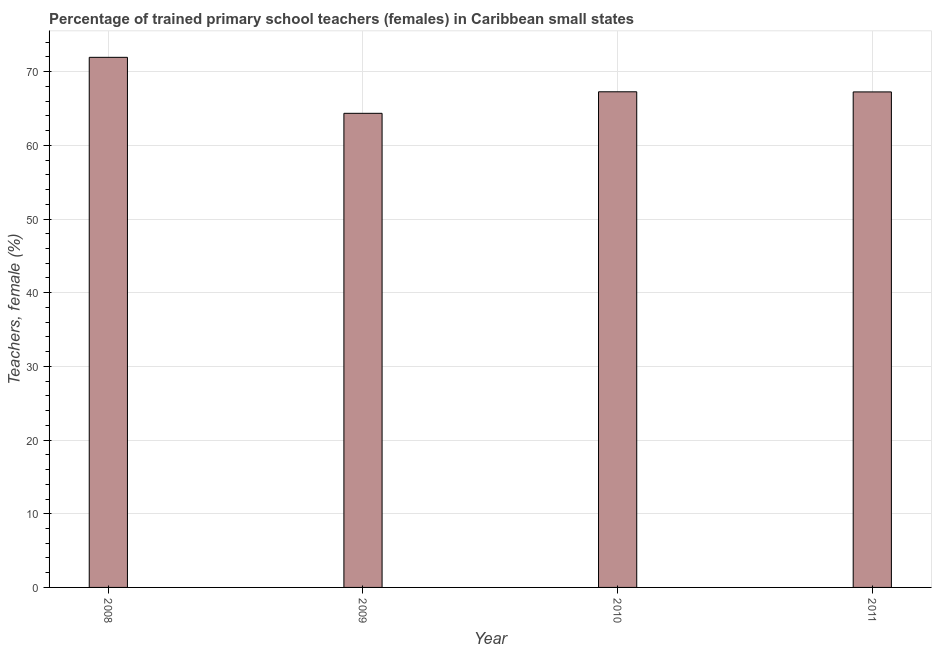Does the graph contain grids?
Your answer should be very brief. Yes. What is the title of the graph?
Your answer should be compact. Percentage of trained primary school teachers (females) in Caribbean small states. What is the label or title of the X-axis?
Ensure brevity in your answer.  Year. What is the label or title of the Y-axis?
Offer a very short reply. Teachers, female (%). What is the percentage of trained female teachers in 2010?
Make the answer very short. 67.27. Across all years, what is the maximum percentage of trained female teachers?
Your answer should be compact. 71.95. Across all years, what is the minimum percentage of trained female teachers?
Give a very brief answer. 64.35. In which year was the percentage of trained female teachers minimum?
Make the answer very short. 2009. What is the sum of the percentage of trained female teachers?
Give a very brief answer. 270.83. What is the difference between the percentage of trained female teachers in 2009 and 2011?
Your response must be concise. -2.9. What is the average percentage of trained female teachers per year?
Make the answer very short. 67.71. What is the median percentage of trained female teachers?
Your answer should be compact. 67.26. Do a majority of the years between 2009 and 2010 (inclusive) have percentage of trained female teachers greater than 14 %?
Provide a succinct answer. Yes. What is the ratio of the percentage of trained female teachers in 2008 to that in 2010?
Provide a succinct answer. 1.07. Is the difference between the percentage of trained female teachers in 2008 and 2010 greater than the difference between any two years?
Your answer should be compact. No. What is the difference between the highest and the second highest percentage of trained female teachers?
Offer a very short reply. 4.68. In how many years, is the percentage of trained female teachers greater than the average percentage of trained female teachers taken over all years?
Your answer should be very brief. 1. Are all the bars in the graph horizontal?
Ensure brevity in your answer.  No. What is the difference between two consecutive major ticks on the Y-axis?
Keep it short and to the point. 10. What is the Teachers, female (%) of 2008?
Your response must be concise. 71.95. What is the Teachers, female (%) in 2009?
Make the answer very short. 64.35. What is the Teachers, female (%) of 2010?
Make the answer very short. 67.27. What is the Teachers, female (%) in 2011?
Offer a terse response. 67.26. What is the difference between the Teachers, female (%) in 2008 and 2009?
Make the answer very short. 7.6. What is the difference between the Teachers, female (%) in 2008 and 2010?
Make the answer very short. 4.68. What is the difference between the Teachers, female (%) in 2008 and 2011?
Give a very brief answer. 4.69. What is the difference between the Teachers, female (%) in 2009 and 2010?
Your answer should be compact. -2.92. What is the difference between the Teachers, female (%) in 2009 and 2011?
Offer a very short reply. -2.9. What is the difference between the Teachers, female (%) in 2010 and 2011?
Offer a terse response. 0.02. What is the ratio of the Teachers, female (%) in 2008 to that in 2009?
Ensure brevity in your answer.  1.12. What is the ratio of the Teachers, female (%) in 2008 to that in 2010?
Keep it short and to the point. 1.07. What is the ratio of the Teachers, female (%) in 2008 to that in 2011?
Give a very brief answer. 1.07. What is the ratio of the Teachers, female (%) in 2009 to that in 2011?
Offer a very short reply. 0.96. 